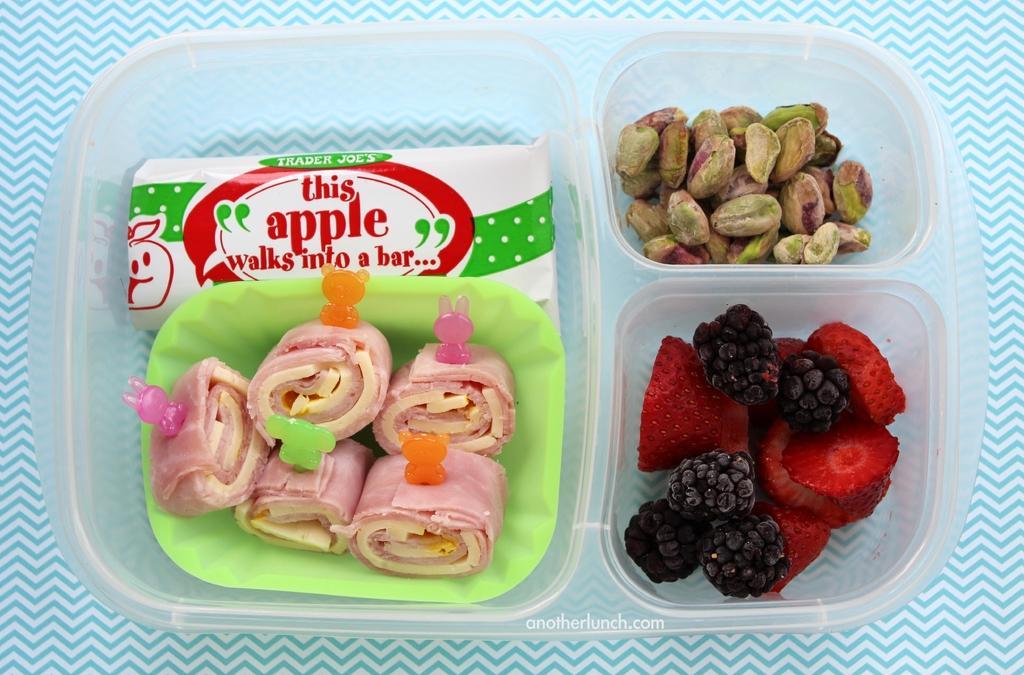Could you give a brief overview of what you see in this image? This image consist of food which is in the box in the center and there is a paper object which is in the box with some text written on it. 